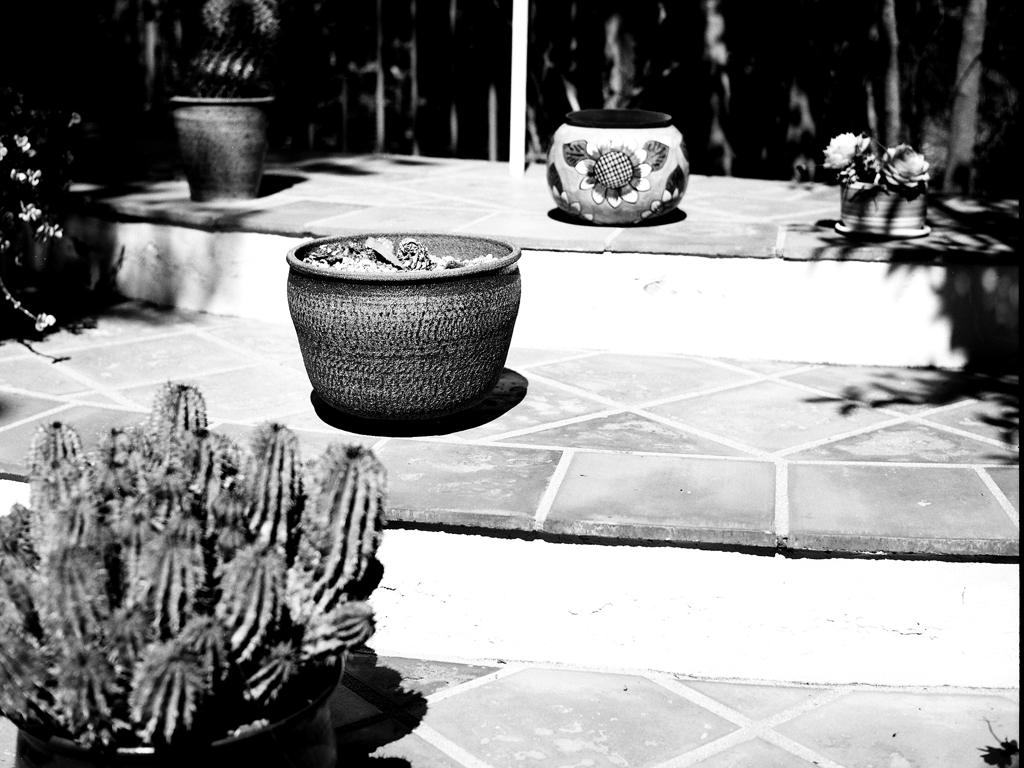What is the overall quality of this image? The image is of average quality in terms of composition and exposure. It captures an outdoor scene with various potted plants and cacti in a setting that suggests a home garden or patio. The black and white filter adds a classic and timeless feel, although some details are lost in the shadows due to high-contrast lighting. The focus is adequate, with the main subjects being the potted plants, which are well-centered. However, the image may benefit from a better balance of light and shadow to enhance detail and texture. 